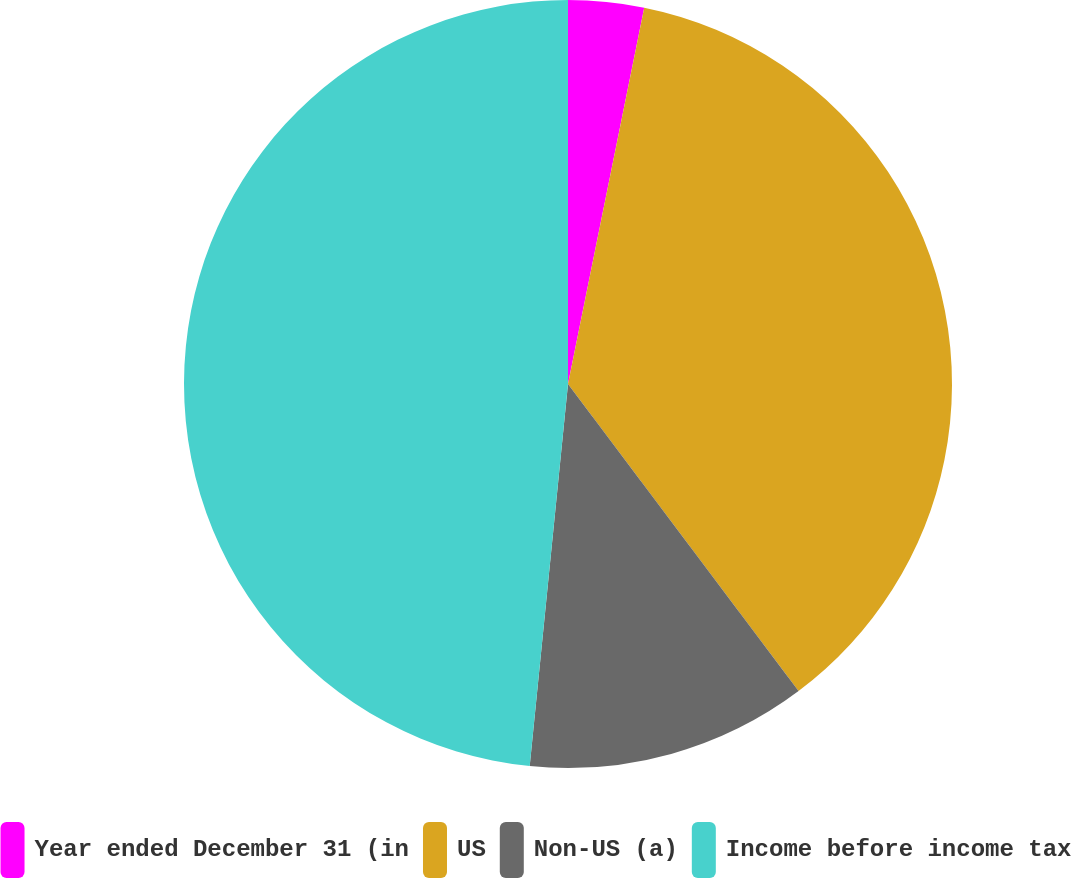Convert chart to OTSL. <chart><loc_0><loc_0><loc_500><loc_500><pie_chart><fcel>Year ended December 31 (in<fcel>US<fcel>Non-US (a)<fcel>Income before income tax<nl><fcel>3.18%<fcel>36.57%<fcel>11.84%<fcel>48.41%<nl></chart> 